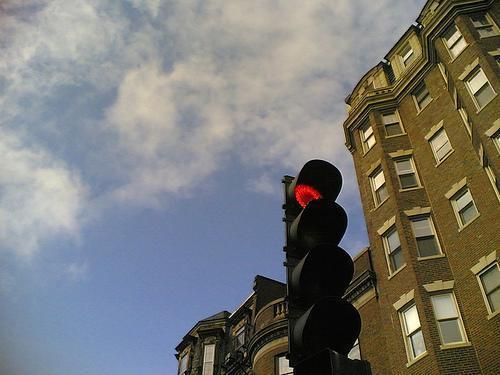How many bananas are there?
Give a very brief answer. 0. 